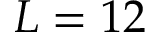<formula> <loc_0><loc_0><loc_500><loc_500>L = 1 2</formula> 